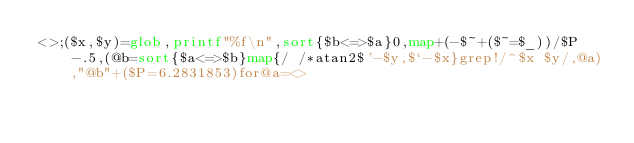<code> <loc_0><loc_0><loc_500><loc_500><_Perl_><>;($x,$y)=glob,printf"%f\n",sort{$b<=>$a}0,map+(-$~+($~=$_))/$P-.5,(@b=sort{$a<=>$b}map{/ /*atan2$'-$y,$`-$x}grep!/^$x $y/,@a),"@b"+($P=6.2831853)for@a=<></code> 